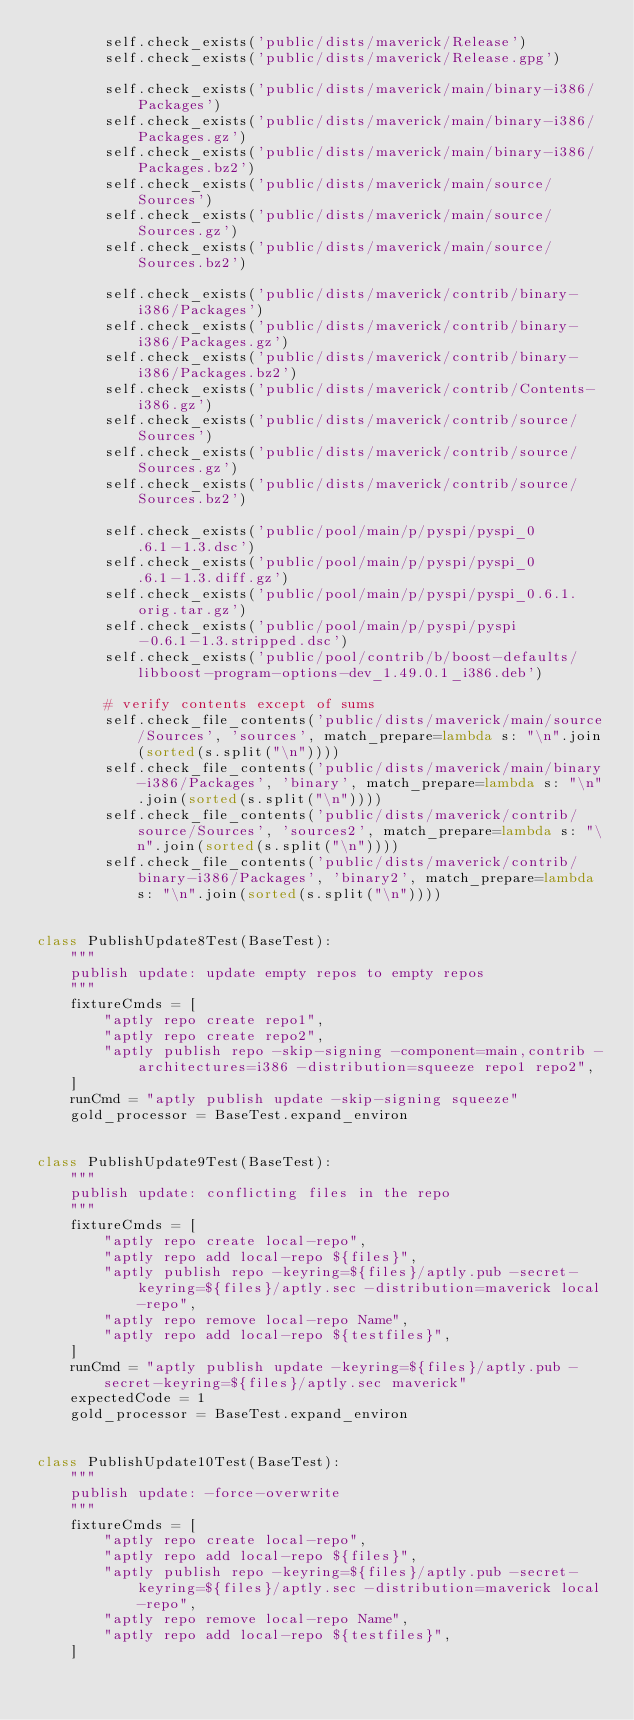Convert code to text. <code><loc_0><loc_0><loc_500><loc_500><_Python_>        self.check_exists('public/dists/maverick/Release')
        self.check_exists('public/dists/maverick/Release.gpg')

        self.check_exists('public/dists/maverick/main/binary-i386/Packages')
        self.check_exists('public/dists/maverick/main/binary-i386/Packages.gz')
        self.check_exists('public/dists/maverick/main/binary-i386/Packages.bz2')
        self.check_exists('public/dists/maverick/main/source/Sources')
        self.check_exists('public/dists/maverick/main/source/Sources.gz')
        self.check_exists('public/dists/maverick/main/source/Sources.bz2')

        self.check_exists('public/dists/maverick/contrib/binary-i386/Packages')
        self.check_exists('public/dists/maverick/contrib/binary-i386/Packages.gz')
        self.check_exists('public/dists/maverick/contrib/binary-i386/Packages.bz2')
        self.check_exists('public/dists/maverick/contrib/Contents-i386.gz')
        self.check_exists('public/dists/maverick/contrib/source/Sources')
        self.check_exists('public/dists/maverick/contrib/source/Sources.gz')
        self.check_exists('public/dists/maverick/contrib/source/Sources.bz2')

        self.check_exists('public/pool/main/p/pyspi/pyspi_0.6.1-1.3.dsc')
        self.check_exists('public/pool/main/p/pyspi/pyspi_0.6.1-1.3.diff.gz')
        self.check_exists('public/pool/main/p/pyspi/pyspi_0.6.1.orig.tar.gz')
        self.check_exists('public/pool/main/p/pyspi/pyspi-0.6.1-1.3.stripped.dsc')
        self.check_exists('public/pool/contrib/b/boost-defaults/libboost-program-options-dev_1.49.0.1_i386.deb')

        # verify contents except of sums
        self.check_file_contents('public/dists/maverick/main/source/Sources', 'sources', match_prepare=lambda s: "\n".join(sorted(s.split("\n"))))
        self.check_file_contents('public/dists/maverick/main/binary-i386/Packages', 'binary', match_prepare=lambda s: "\n".join(sorted(s.split("\n"))))
        self.check_file_contents('public/dists/maverick/contrib/source/Sources', 'sources2', match_prepare=lambda s: "\n".join(sorted(s.split("\n"))))
        self.check_file_contents('public/dists/maverick/contrib/binary-i386/Packages', 'binary2', match_prepare=lambda s: "\n".join(sorted(s.split("\n"))))


class PublishUpdate8Test(BaseTest):
    """
    publish update: update empty repos to empty repos
    """
    fixtureCmds = [
        "aptly repo create repo1",
        "aptly repo create repo2",
        "aptly publish repo -skip-signing -component=main,contrib -architectures=i386 -distribution=squeeze repo1 repo2",
    ]
    runCmd = "aptly publish update -skip-signing squeeze"
    gold_processor = BaseTest.expand_environ


class PublishUpdate9Test(BaseTest):
    """
    publish update: conflicting files in the repo
    """
    fixtureCmds = [
        "aptly repo create local-repo",
        "aptly repo add local-repo ${files}",
        "aptly publish repo -keyring=${files}/aptly.pub -secret-keyring=${files}/aptly.sec -distribution=maverick local-repo",
        "aptly repo remove local-repo Name",
        "aptly repo add local-repo ${testfiles}",
    ]
    runCmd = "aptly publish update -keyring=${files}/aptly.pub -secret-keyring=${files}/aptly.sec maverick"
    expectedCode = 1
    gold_processor = BaseTest.expand_environ


class PublishUpdate10Test(BaseTest):
    """
    publish update: -force-overwrite
    """
    fixtureCmds = [
        "aptly repo create local-repo",
        "aptly repo add local-repo ${files}",
        "aptly publish repo -keyring=${files}/aptly.pub -secret-keyring=${files}/aptly.sec -distribution=maverick local-repo",
        "aptly repo remove local-repo Name",
        "aptly repo add local-repo ${testfiles}",
    ]</code> 